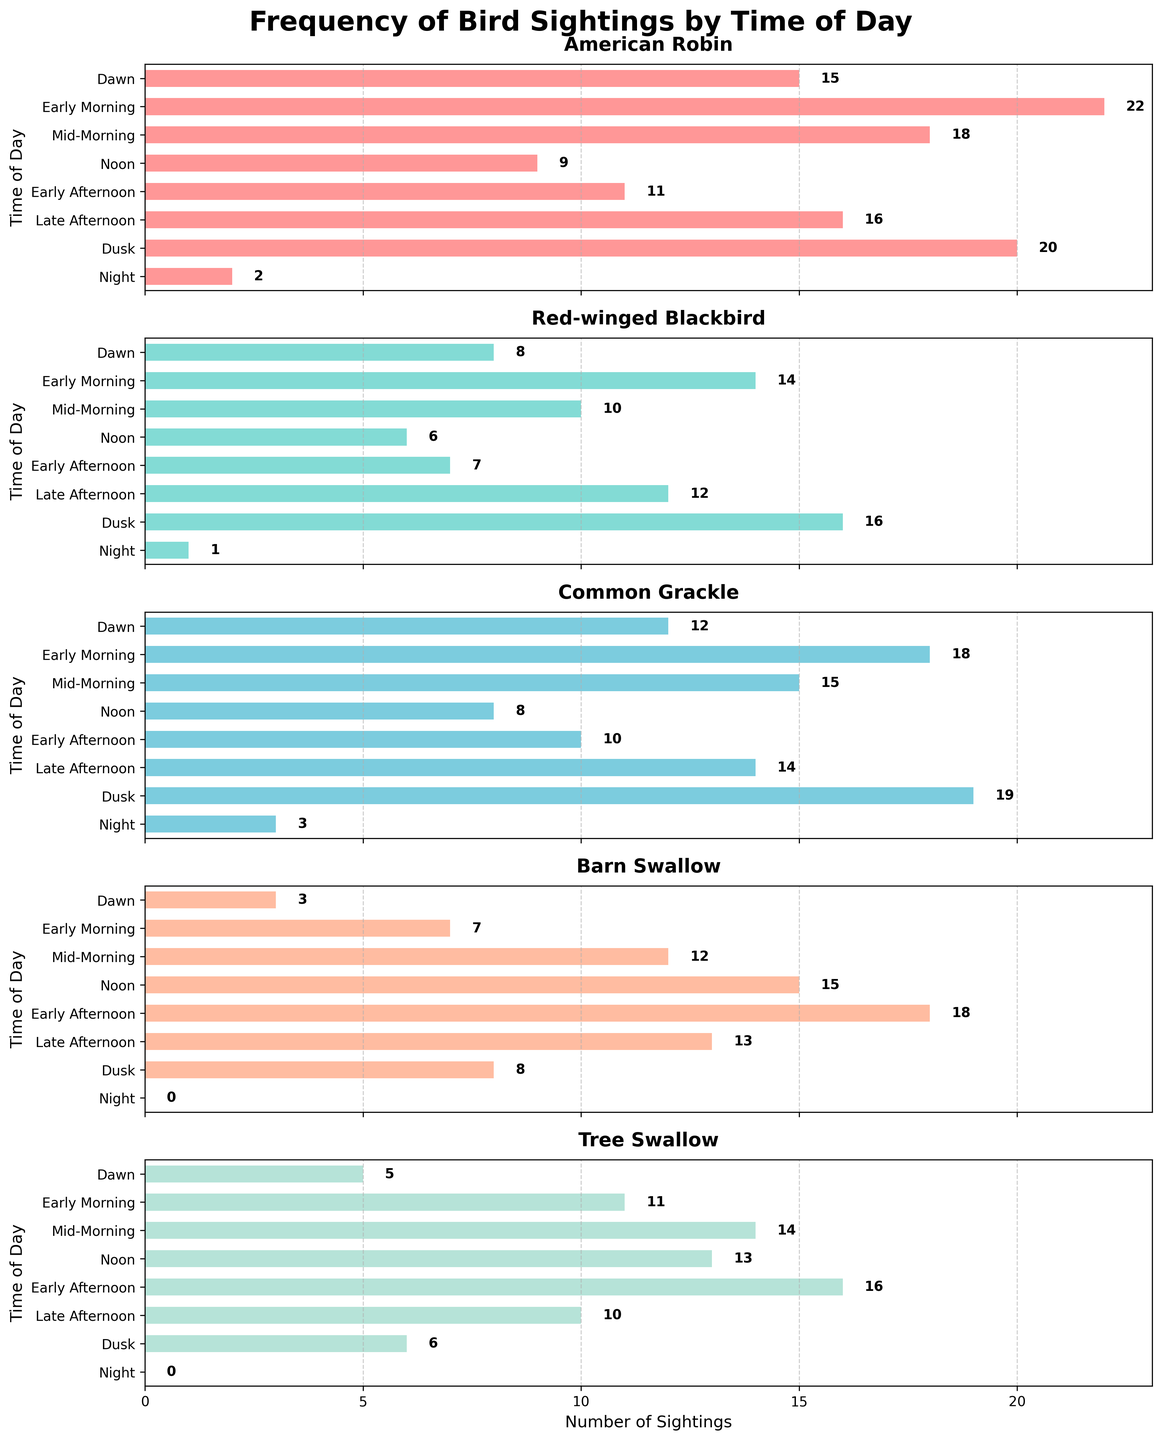What's the most common bird observed at Dawn? Look at the bar chart for the Dawn section across all birds. The highest bar corresponds to the American Robin with 15 sightings.
Answer: American Robin Which bird has the highest sightings during Early Morning? Refer to the Early Morning section. The highest bar here corresponds to the Common Grackle with 18 sightings.
Answer: Common Grackle What's the difference in the number of sightings of American Robin between Dawn and Dusk? The American Robin has 15 sightings at Dawn and 20 at Dusk. The difference is 20 - 15 = 5.
Answer: 5 How many birds have more sightings at Noon than at Dawn? Compare the bars for Noon and Dawn for each bird: Barn Swallow (15 vs. 3) and Tree Swallow (13 vs. 5) are the only ones with more sightings at Noon.
Answer: 2 What time of day does the Red-winged Blackbird have the fewest sightings? Determine which section has the smallest bar for Red-winged Blackbird, which is Night with 1 sighting.
Answer: Night Which bird exhibits the largest increase in sightings from Early Morning to Mid-Morning? Calculate the increase: American Robin (18 - 22 = -4), Red-winged Blackbird (10 - 14 = -4), Common Grackle (15 - 18 = -3), Barn Swallow (12 - 7 = 5), Tree Swallow (14 - 11 = 3). Barn Swallow shows the largest increase of 5.
Answer: Barn Swallow During which period are Barn Swallows most frequently sighted? Look at the Barn Swallow subplot and identify the period with the highest bar, which is Early Afternoon with 18 sightings.
Answer: Early Afternoon What is the sum of sightings of Tree Swallows from Dawn to Early Morning? Add the Tree Swallow sightings at Dawn and Early Morning: 5 (Dawn) + 11 (Early Morning) = 16.
Answer: 16 Which bird has the most sightings at Night? Evaluate the bars for Night across all birds. American Robin with 2 sightings has the highest count.
Answer: American Robin 